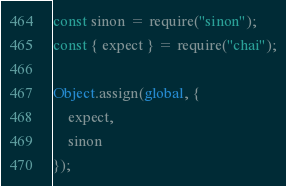<code> <loc_0><loc_0><loc_500><loc_500><_JavaScript_>const sinon = require("sinon");
const { expect } = require("chai");

Object.assign(global, {
    expect,
    sinon
});
</code> 